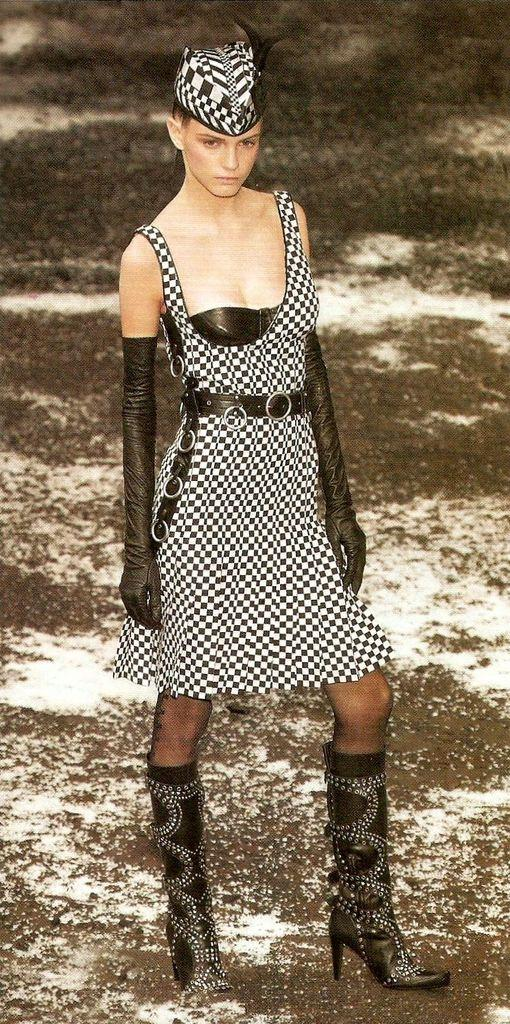What is the main subject of the image? There is a woman standing in the image. Can you describe the background of the image? There is land visible in the background of the image. What type of silk is the woman wearing in the image? There is no mention of silk or any specific clothing in the image, so it cannot be determined what the woman might be wearing. 